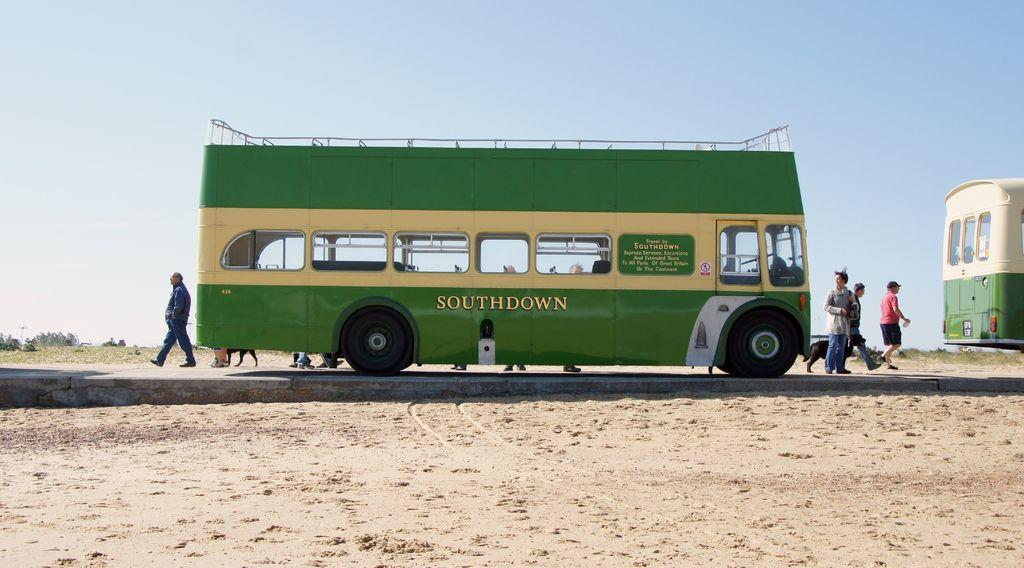<image>
Offer a succinct explanation of the picture presented. A green and yellow bus with the word Southdown on the side is parked by the sand, people milling about it. 